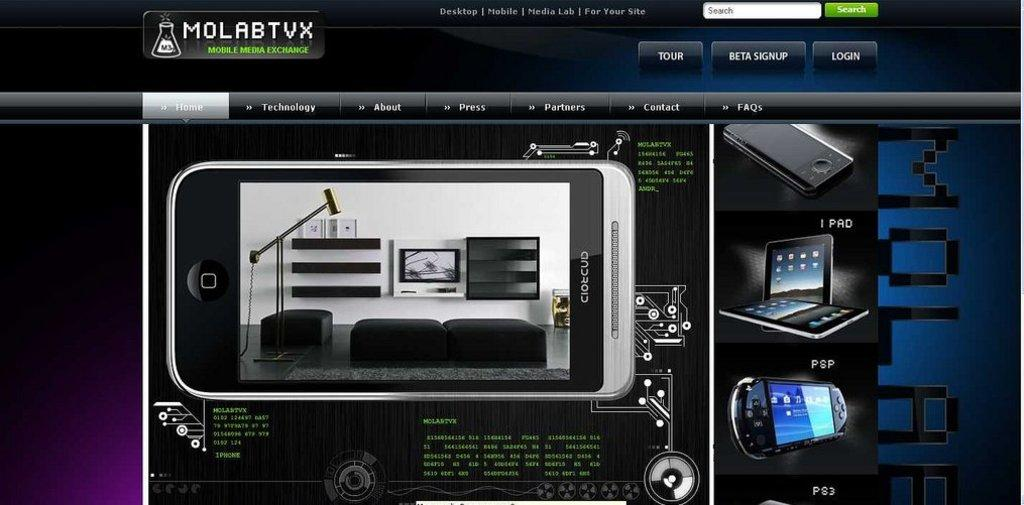<image>
Create a compact narrative representing the image presented. A webpage that is entitled Molabtvx which is a mobile media exchange. 